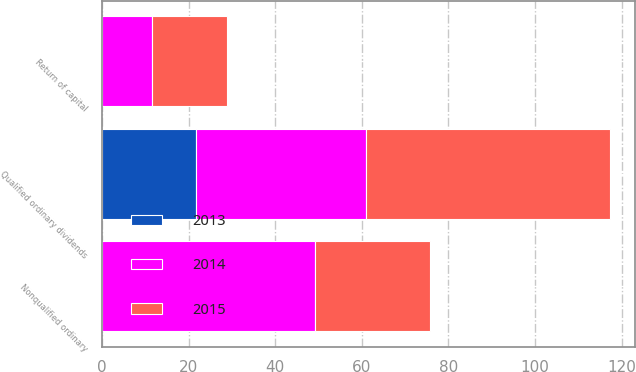<chart> <loc_0><loc_0><loc_500><loc_500><stacked_bar_chart><ecel><fcel>Nonqualified ordinary<fcel>Qualified ordinary dividends<fcel>Return of capital<nl><fcel>2013<fcel>0<fcel>21.8<fcel>0<nl><fcel>2015<fcel>26.4<fcel>56.4<fcel>17.2<nl><fcel>2014<fcel>49.3<fcel>39.1<fcel>11.6<nl></chart> 